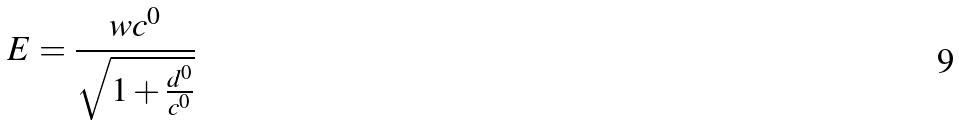Convert formula to latex. <formula><loc_0><loc_0><loc_500><loc_500>E = \frac { w c ^ { 0 } } { \sqrt { 1 + \frac { d ^ { 0 } } { c ^ { 0 } } } }</formula> 